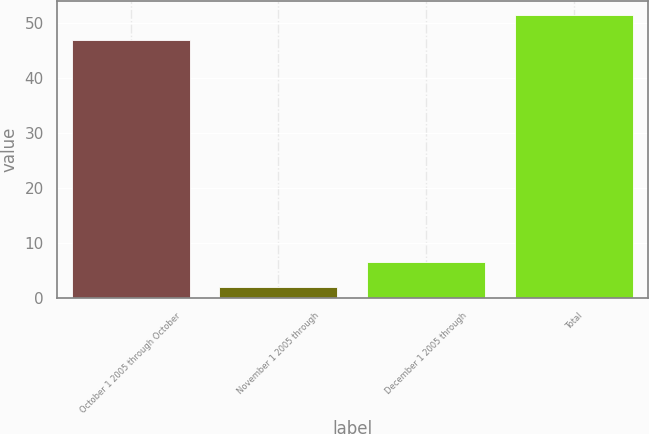<chart> <loc_0><loc_0><loc_500><loc_500><bar_chart><fcel>October 1 2005 through October<fcel>November 1 2005 through<fcel>December 1 2005 through<fcel>Total<nl><fcel>46.93<fcel>2<fcel>6.49<fcel>51.42<nl></chart> 